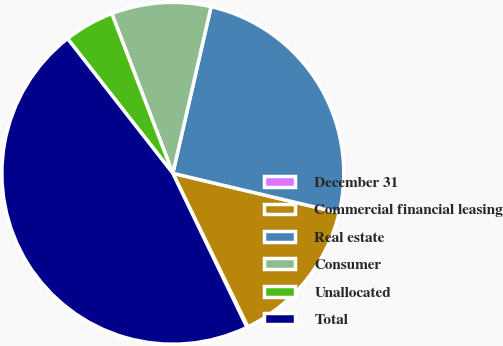<chart> <loc_0><loc_0><loc_500><loc_500><pie_chart><fcel>December 31<fcel>Commercial financial leasing<fcel>Real estate<fcel>Consumer<fcel>Unallocated<fcel>Total<nl><fcel>0.1%<fcel>14.05%<fcel>25.12%<fcel>9.4%<fcel>4.75%<fcel>46.58%<nl></chart> 